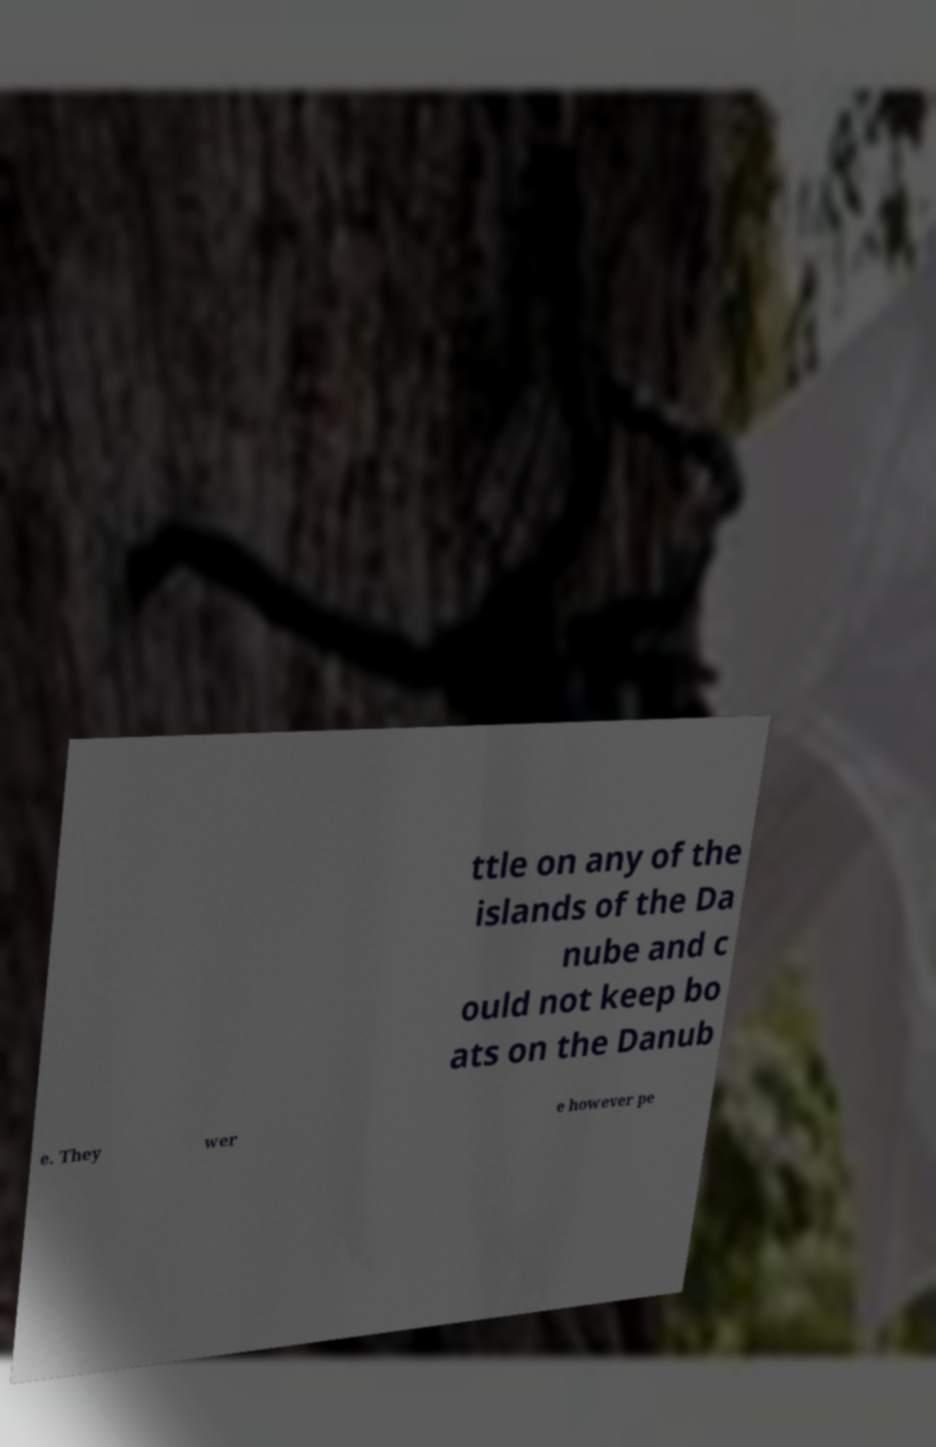I need the written content from this picture converted into text. Can you do that? ttle on any of the islands of the Da nube and c ould not keep bo ats on the Danub e. They wer e however pe 